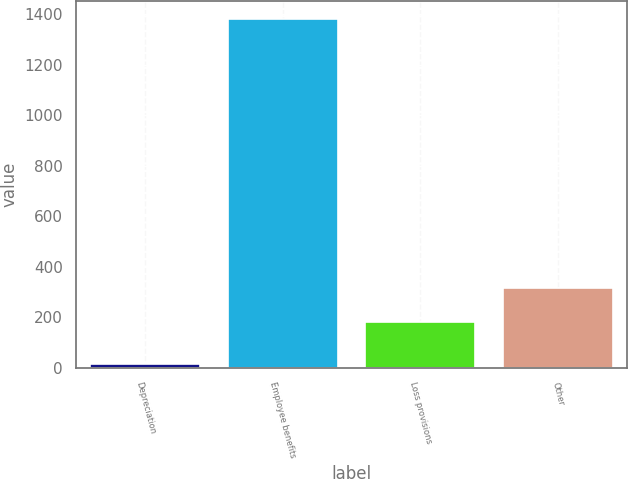Convert chart. <chart><loc_0><loc_0><loc_500><loc_500><bar_chart><fcel>Depreciation<fcel>Employee benefits<fcel>Loss provisions<fcel>Other<nl><fcel>15<fcel>1382<fcel>181<fcel>317.7<nl></chart> 